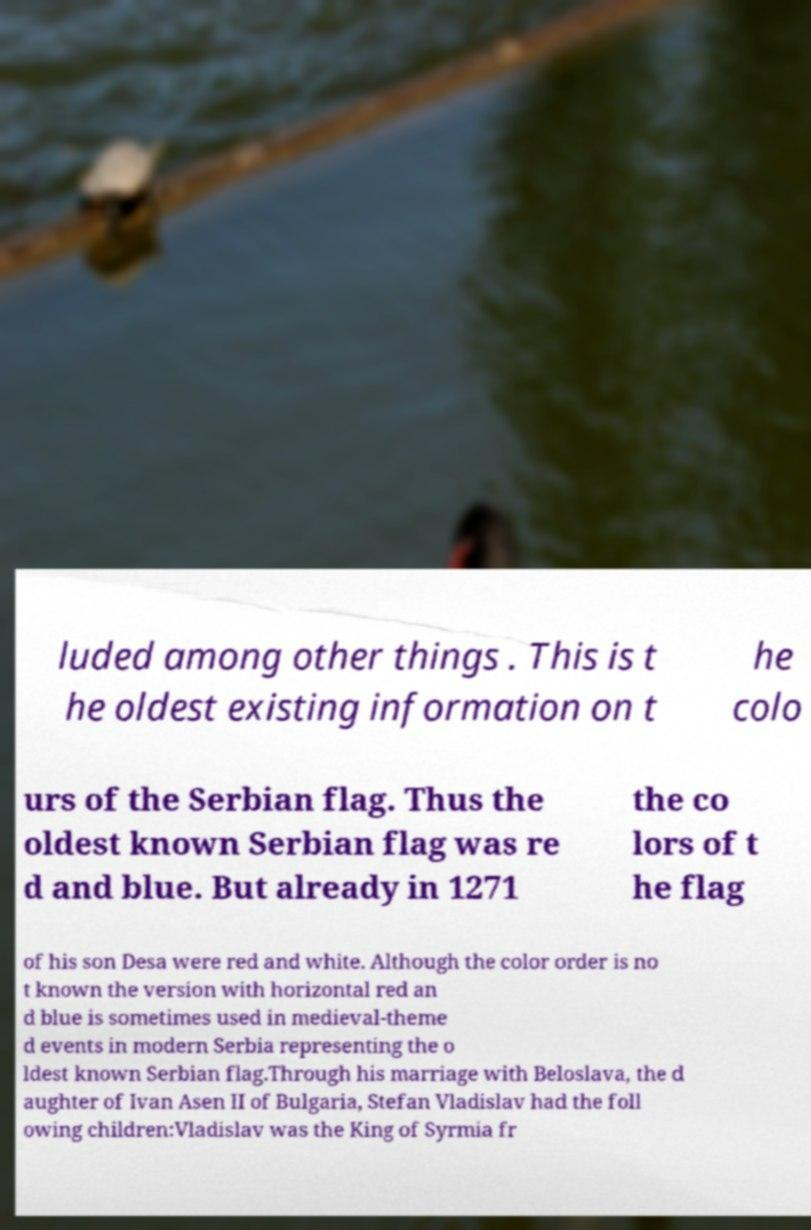What messages or text are displayed in this image? I need them in a readable, typed format. luded among other things . This is t he oldest existing information on t he colo urs of the Serbian flag. Thus the oldest known Serbian flag was re d and blue. But already in 1271 the co lors of t he flag of his son Desa were red and white. Although the color order is no t known the version with horizontal red an d blue is sometimes used in medieval-theme d events in modern Serbia representing the o ldest known Serbian flag.Through his marriage with Beloslava, the d aughter of Ivan Asen II of Bulgaria, Stefan Vladislav had the foll owing children:Vladislav was the King of Syrmia fr 